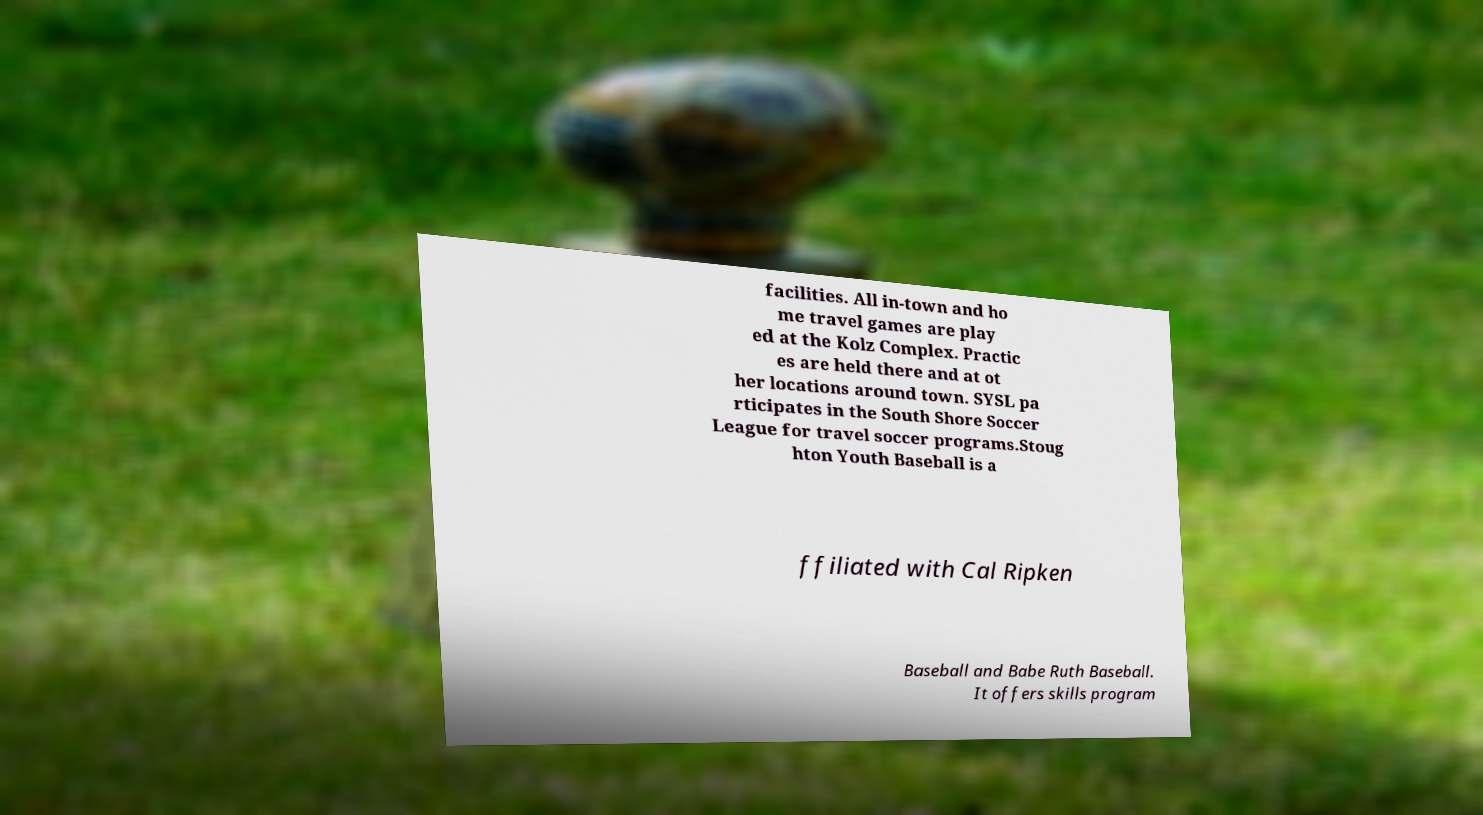Can you accurately transcribe the text from the provided image for me? facilities. All in-town and ho me travel games are play ed at the Kolz Complex. Practic es are held there and at ot her locations around town. SYSL pa rticipates in the South Shore Soccer League for travel soccer programs.Stoug hton Youth Baseball is a ffiliated with Cal Ripken Baseball and Babe Ruth Baseball. It offers skills program 